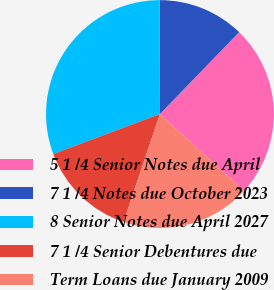Convert chart. <chart><loc_0><loc_0><loc_500><loc_500><pie_chart><fcel>5 1 /4 Senior Notes due April<fcel>7 1 /4 Notes due October 2023<fcel>8 Senior Notes due April 2027<fcel>7 1 /4 Senior Debentures due<fcel>Term Loans due January 2009<nl><fcel>24.54%<fcel>12.27%<fcel>30.67%<fcel>14.11%<fcel>18.4%<nl></chart> 